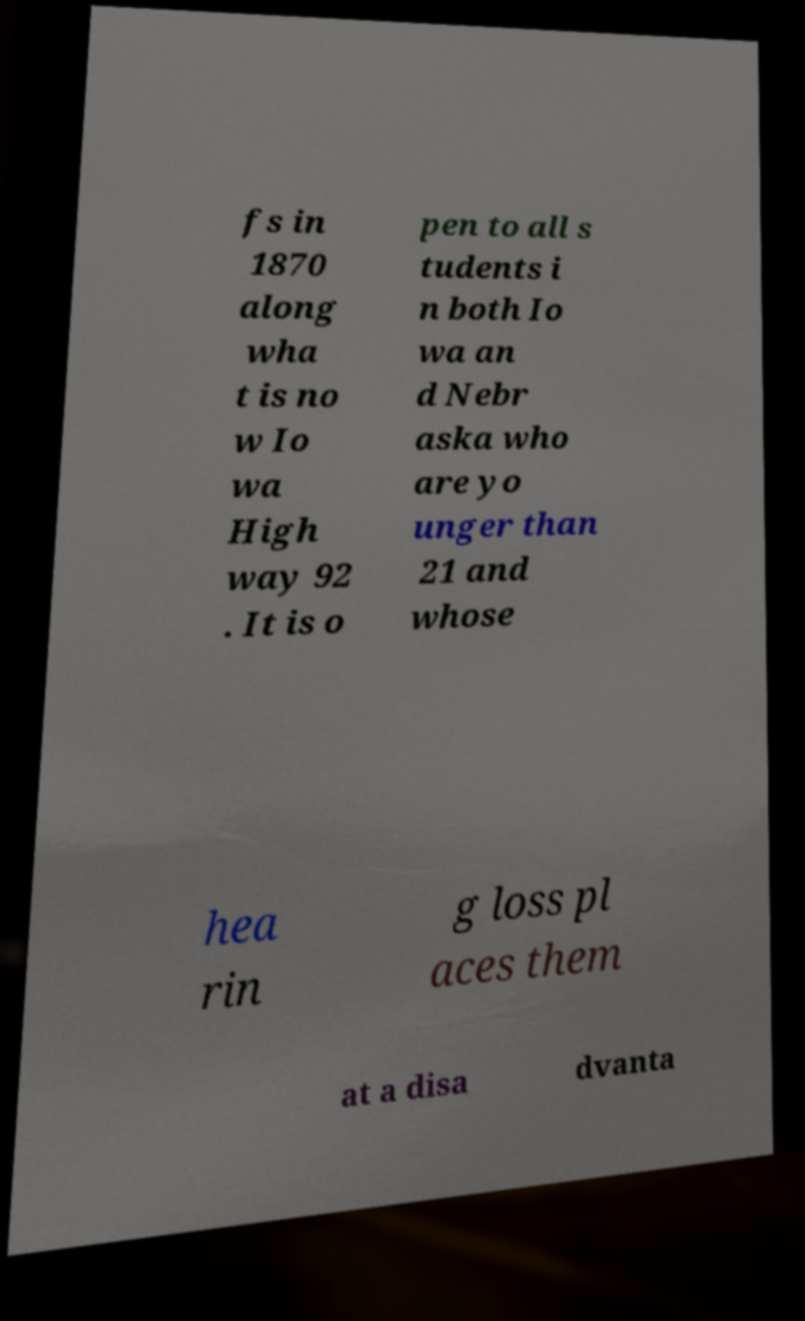I need the written content from this picture converted into text. Can you do that? fs in 1870 along wha t is no w Io wa High way 92 . It is o pen to all s tudents i n both Io wa an d Nebr aska who are yo unger than 21 and whose hea rin g loss pl aces them at a disa dvanta 